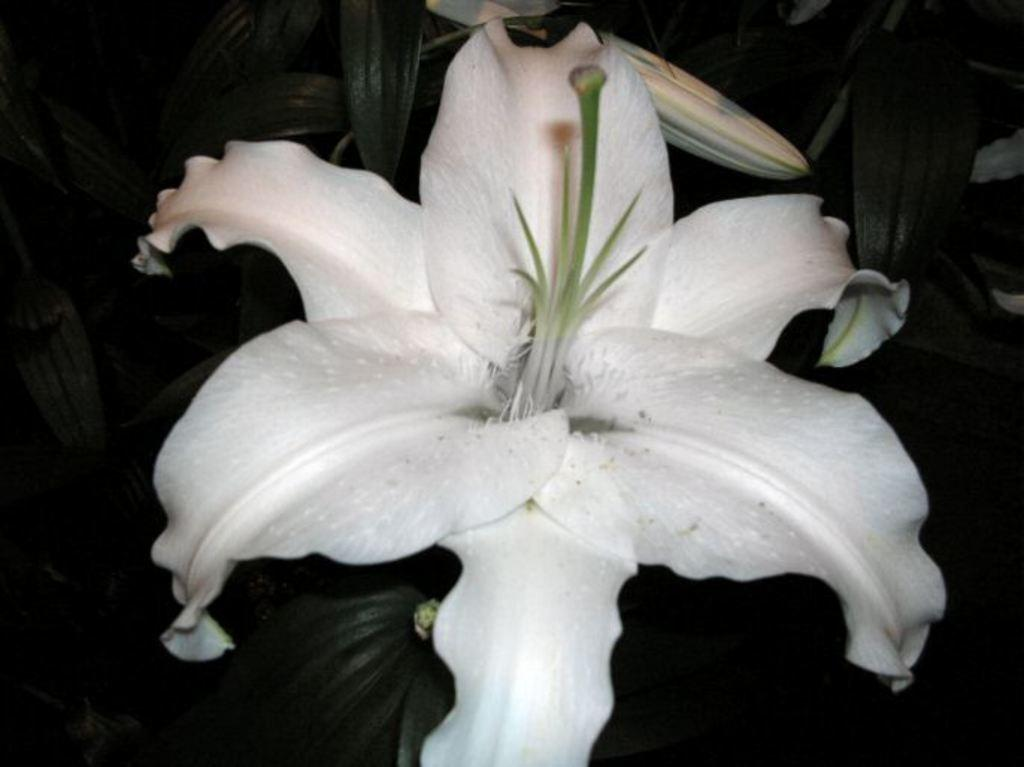What is the main subject of the image? There is a flower in the middle of the image. What can be seen in the background of the image? There are leaves visible in the background of the image. Can you see an airplane flying over the flower in the image? There is no airplane visible in the image; it only features a flower and leaves in the background. 